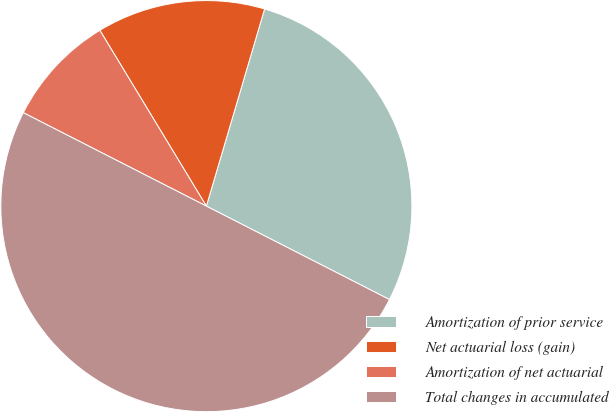Convert chart to OTSL. <chart><loc_0><loc_0><loc_500><loc_500><pie_chart><fcel>Amortization of prior service<fcel>Net actuarial loss (gain)<fcel>Amortization of net actuarial<fcel>Total changes in accumulated<nl><fcel>27.94%<fcel>13.24%<fcel>8.82%<fcel>50.0%<nl></chart> 